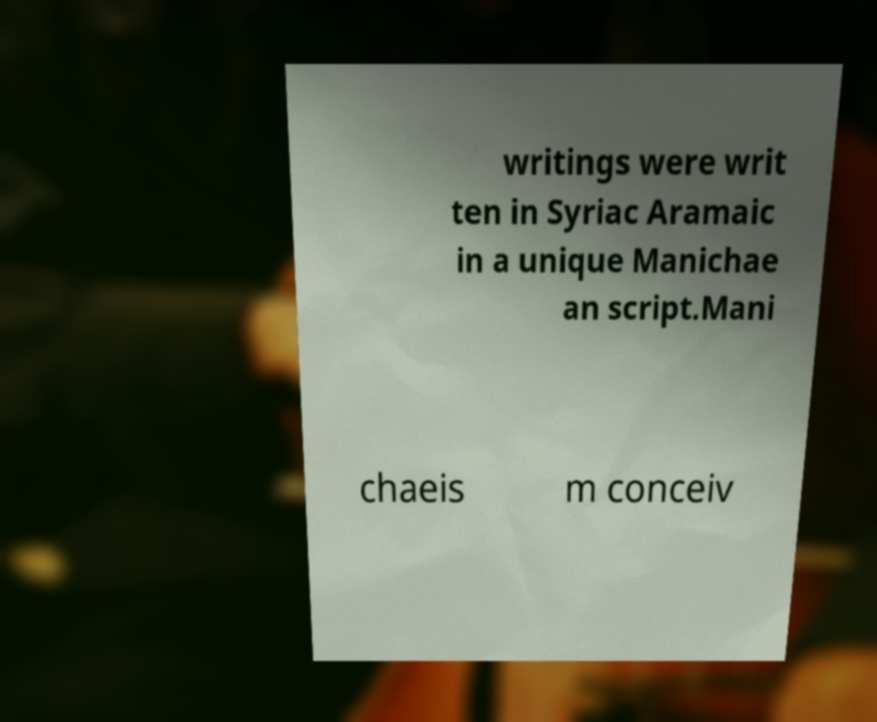What messages or text are displayed in this image? I need them in a readable, typed format. writings were writ ten in Syriac Aramaic in a unique Manichae an script.Mani chaeis m conceiv 